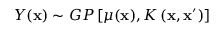Convert formula to latex. <formula><loc_0><loc_0><loc_500><loc_500>Y ( x ) \sim G P \left [ \mu ( x ) , K \left ( x , x ^ { \prime } \right ) \right ]</formula> 